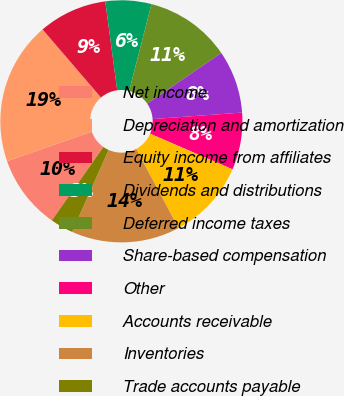Convert chart to OTSL. <chart><loc_0><loc_0><loc_500><loc_500><pie_chart><fcel>Net income<fcel>Depreciation and amortization<fcel>Equity income from affiliates<fcel>Dividends and distributions<fcel>Deferred income taxes<fcel>Share-based compensation<fcel>Other<fcel>Accounts receivable<fcel>Inventories<fcel>Trade accounts payable<nl><fcel>9.92%<fcel>19.06%<fcel>9.16%<fcel>6.12%<fcel>11.45%<fcel>8.4%<fcel>7.64%<fcel>10.69%<fcel>14.49%<fcel>3.07%<nl></chart> 